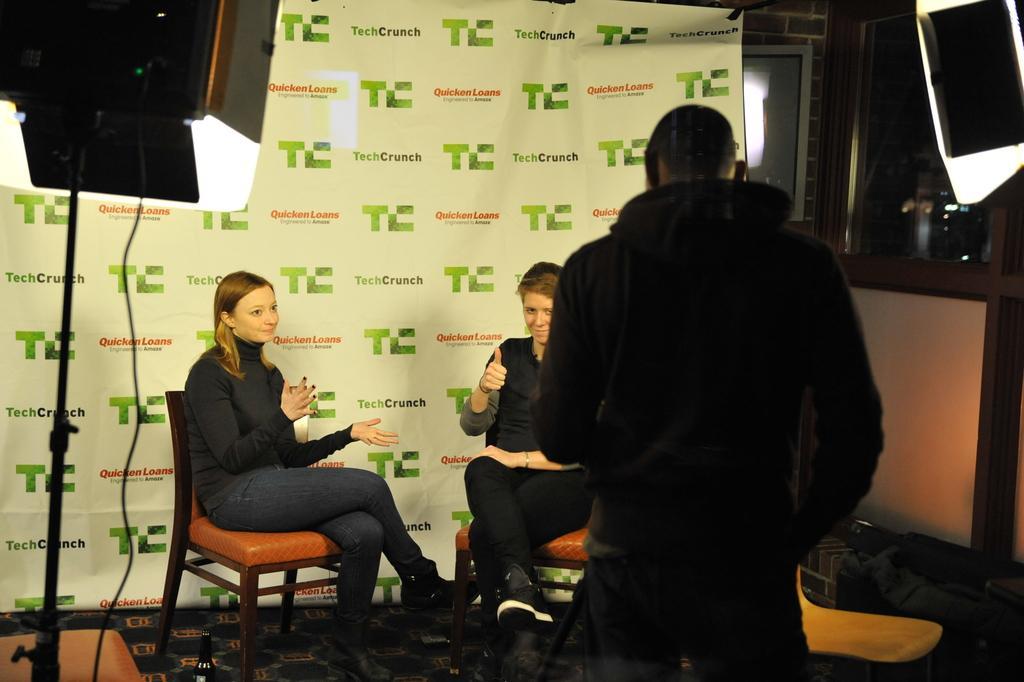Describe this image in one or two sentences. In this image, There are some people sitting on the chairs, on the right side there is a man standing,=nd in the background there is a white color wall and in the left side there is a black color light instrument. 